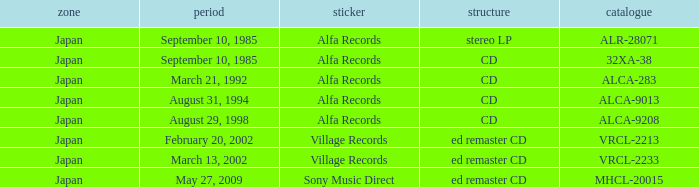Which Catalog was formated as a CD under the label Alfa Records? 32XA-38, ALCA-283, ALCA-9013, ALCA-9208. 